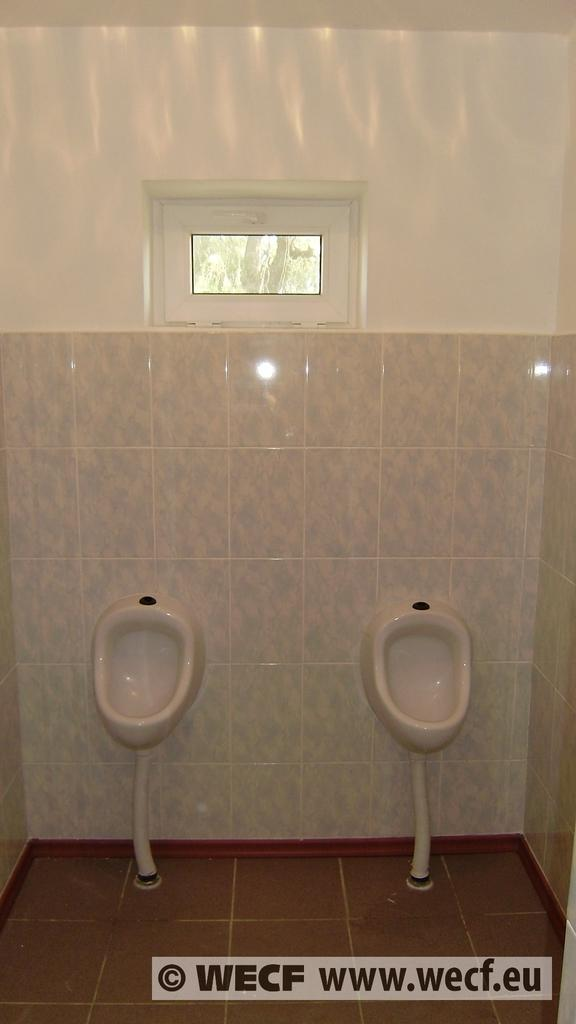How many toilets are present in the image? There are two toilets in the image. What color are the toilets? The toilets are white in color. What color is the background wall in the image? The background wall is white in color. Can you describe any other features in the image? There is a glass door visible in the image. What type of juice is being served in the image? There is no juice present in the image; it features two toilets and a glass door. Can you tell me which prose is being read by the person in the image? There is no person or prose present in the image. 